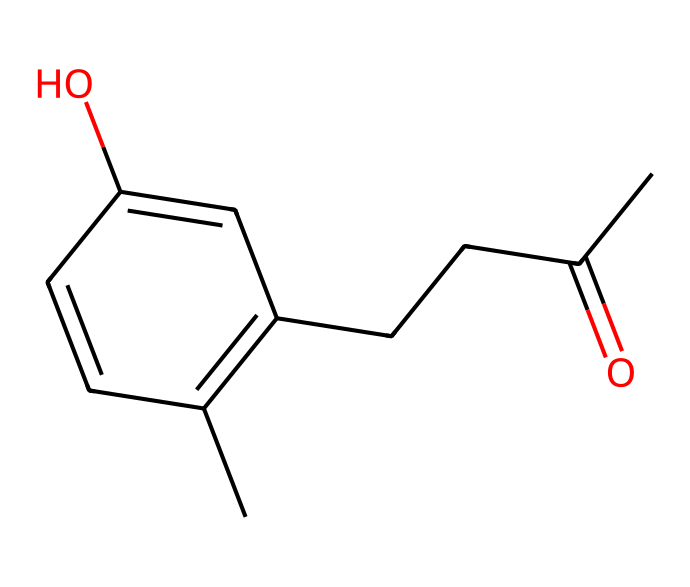How many carbon atoms are in raspberry ketone? By examining the SMILES representation, we count the 'C' symbols, including those in the carbonyl group (C=O). There are 10 carbon atoms in total.
Answer: 10 What functional group is present in raspberry ketone? The presence of the carbonyl group (C=O) suggests this compound belongs to the ketone functional group class.
Answer: ketone How many double bonds are in the structure of raspberry ketone? By analyzing the SMILES, we identify two double bonds: one in the carbonyl group and another in the cyclohexene ring.
Answer: 2 What is the molecular formula for raspberry ketone? To derive the molecular formula, we sum the number of each atom type in the structure, resulting in C10H12O.
Answer: C10H12O What type of compound is raspberry ketone classified as? Based on the presence of the ketone functional group and the overall structure, raspberry ketone is classified as an aromatic compound.
Answer: aromatic Which part of the structure gives raspberry ketone its characteristic aroma? The configuration of the aromatic ring and the side chains contribute significantly to the compound's sensory properties, leading to its pleasant aroma.
Answer: aromatic ring How many hydroxyl groups are in the structure of raspberry ketone? Examining the SMILES shows the presence of one hydroxyl group (-OH), indicating that there is only one in the structure.
Answer: 1 